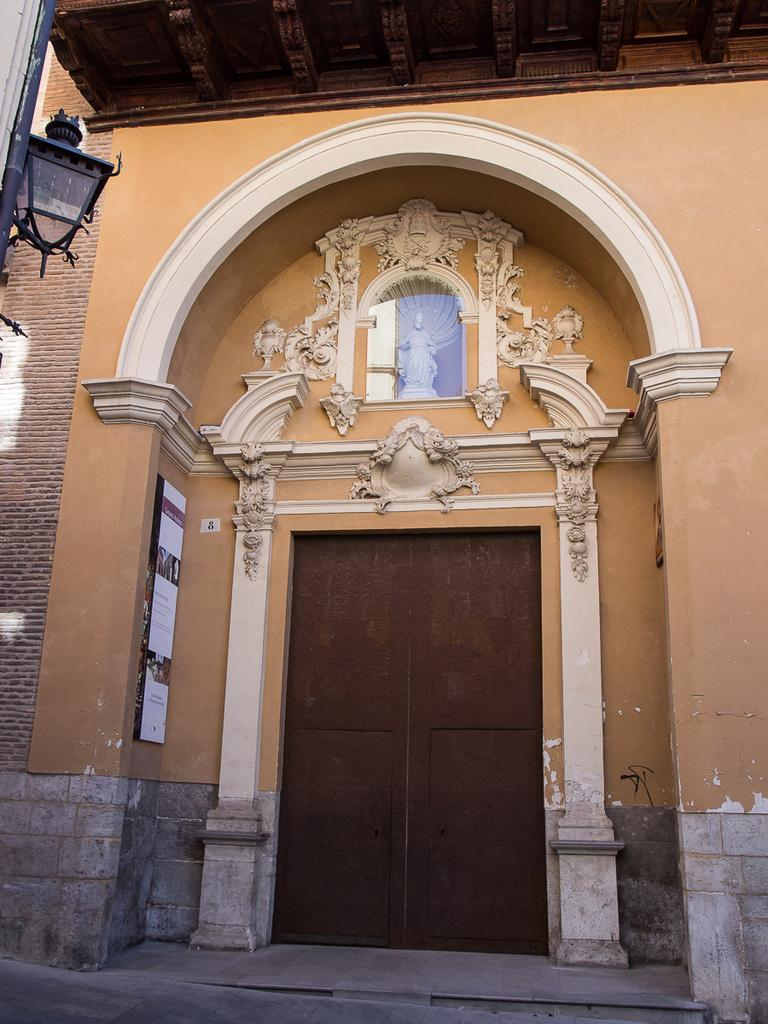What type of structure is present in the image? There is a building in the image. Can you describe the entrance of the building? The building has a door in the middle. What decorative elements are present in front of the building? There are sculptures in front of the building. What additional feature can be seen in front of the building? There is a pillar with a light on it in front of the building. How many fish are swimming on the roof of the building in the image? There are no fish present in the image, and the building does not have a roof. 